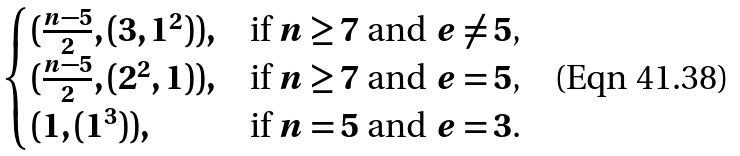<formula> <loc_0><loc_0><loc_500><loc_500>\begin{cases} ( \frac { n - 5 } 2 , ( 3 , 1 ^ { 2 } ) ) , & \text {if $n\geq 7$ and $e\neq 5$, } \\ ( \frac { n - 5 } 2 , ( 2 ^ { 2 } , 1 ) ) , & \text {if $n\geq 7$ and $e= 5$, } \\ ( 1 , ( 1 ^ { 3 } ) ) , & \text {if $n=5$ and $e= 3$.} \\ \end{cases}</formula> 